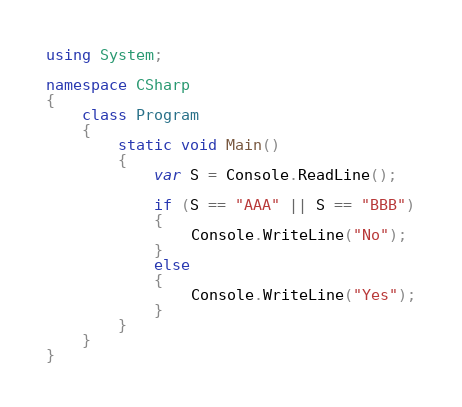Convert code to text. <code><loc_0><loc_0><loc_500><loc_500><_C#_>using System;

namespace CSharp
{
    class Program
    {
        static void Main()
        {
            var S = Console.ReadLine();

            if (S == "AAA" || S == "BBB")
            {
                Console.WriteLine("No");
            }
            else
            {
                Console.WriteLine("Yes");
            }
        }
    }
}</code> 